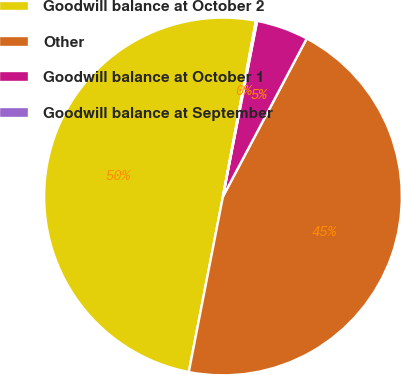Convert chart to OTSL. <chart><loc_0><loc_0><loc_500><loc_500><pie_chart><fcel>Goodwill balance at October 2<fcel>Other<fcel>Goodwill balance at October 1<fcel>Goodwill balance at September<nl><fcel>49.89%<fcel>45.3%<fcel>4.7%<fcel>0.11%<nl></chart> 